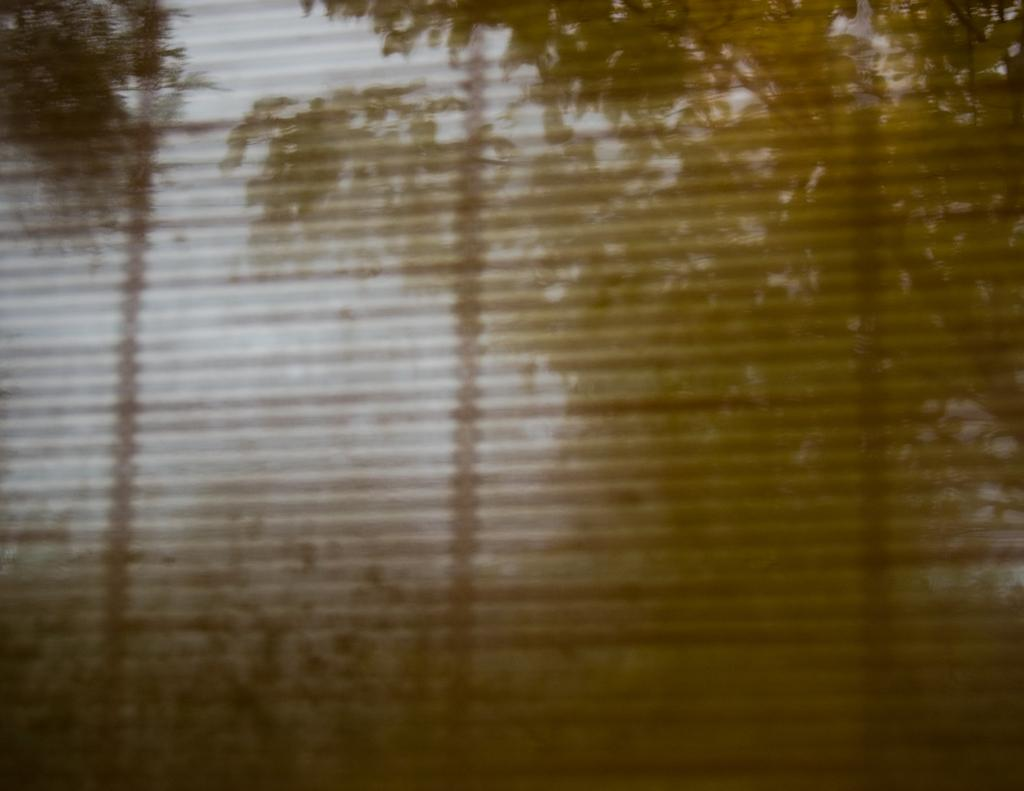What is present in the image that provides a view of the outdoors? There is a window in the image that provides a view of the outdoors. Is the window completely transparent or is it covered? The window is covered in the image. What can be seen through the window despite the covering? Trees and the sky are visible through the window. What rule is being enforced by the trees visible through the window? There is no rule being enforced by the trees visible through the window; they are simply part of the natural landscape. 